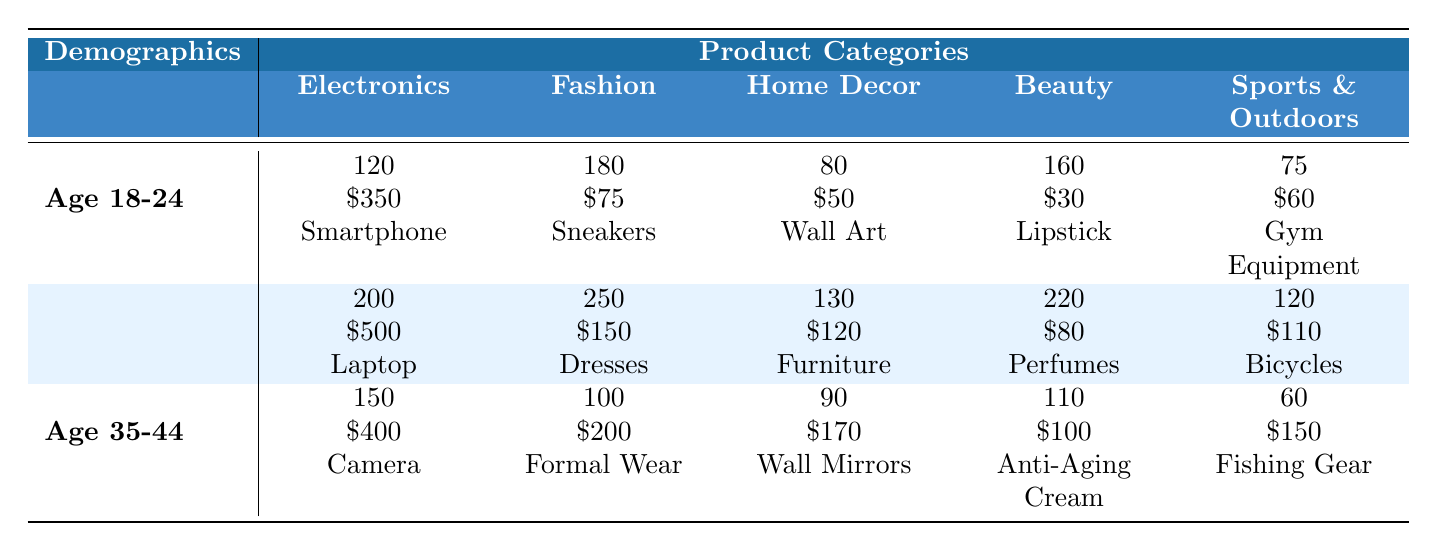What is the purchase frequency for the Electronics category among 18-24-year-olds? From the table, under the Electronics section for Age 18-24, the Purchase Frequency is listed as 120.
Answer: 120 Which product category has the highest average purchase value for the 25-34 age group? Looking at the average purchase values for the 25-34 age group: Electronics is $500, Fashion is $150, Home Decor is $120, Beauty is $80, and Sports & Outdoors is $110. The highest value is $500 for Electronics.
Answer: Electronics How many more purchases were made in the Fashion category compared to Beauty for individuals aged 35-44? For Age 35-44, Fashion has a Purchase Frequency of 100, and Beauty has 110. The difference is 110 - 100 = 10.
Answer: 10 What are the top products for the Home Decor category among the 25-34 age group? In the Home Decor section for Age 25-34, the Top Products listed are Furniture, Rugs, and Candles.
Answer: Furniture, Rugs, and Candles Is the average purchase value higher for the Beauty category than for the Sports & Outdoors category among the 18-24 age group? For Age 18-24, the average purchase value for Beauty is $30, and for Sports & Outdoors it is $60. Since $30 is not higher than $60, the answer is no.
Answer: No What is the total purchase frequency for the age group 25-34 across all product categories? Summing the purchase frequencies for Age 25-34: Electronics (200) + Fashion (250) + Home Decor (130) + Beauty (220) + Sports & Outdoors (120) equals 200 + 250 + 130 + 220 + 120 = 1020.
Answer: 1020 Which product category has the most diverse range of top products for the 18-24 age group? Analyzing the top products for Age 18-24: Electronics (Smartphone, Headphones, Smartwatch), Fashion (Sneakers, T-Shirts, Backpacks), Home Decor (Wall Art, Cushions, Decorative Lights), Beauty (Lipstick, Skincare Sets, Nail Polish), Sports & Outdoors (Gym Equipment, Athletic Shoes, Yoga Mats). All categories have 3 products listed, indicating equal diversity in top products.
Answer: All categories are equally diverse What is the average purchase value for the 35-44 age group across all categories? The average purchase values for Age 35-44 are: Electronics ($400), Fashion ($200), Home Decor ($170), Beauty ($100), and Sports & Outdoors ($150). The average is calculated as (400 + 200 + 170 + 100 + 150) / 5 = 202.
Answer: 202 Which demographic segment shows the highest purchase frequency for Sports & Outdoors? For the Sports & Outdoors category, looking at the purchase frequencies: Age 18-24 is 75, Age 25-34 is 120, Age 35-44 is 60. The highest frequency is 120 for Age 25-34.
Answer: Age 25-34 What is the average purchase value of the products aged 18-24 across all categories? The average purchase values for Age 18-24 are $350 (Electronics), $75 (Fashion), $50 (Home Decor), $30 (Beauty), and $60 (Sports & Outdoors). Calculating the average: (350 + 75 + 50 + 30 + 60) / 5 = 113.
Answer: 113 